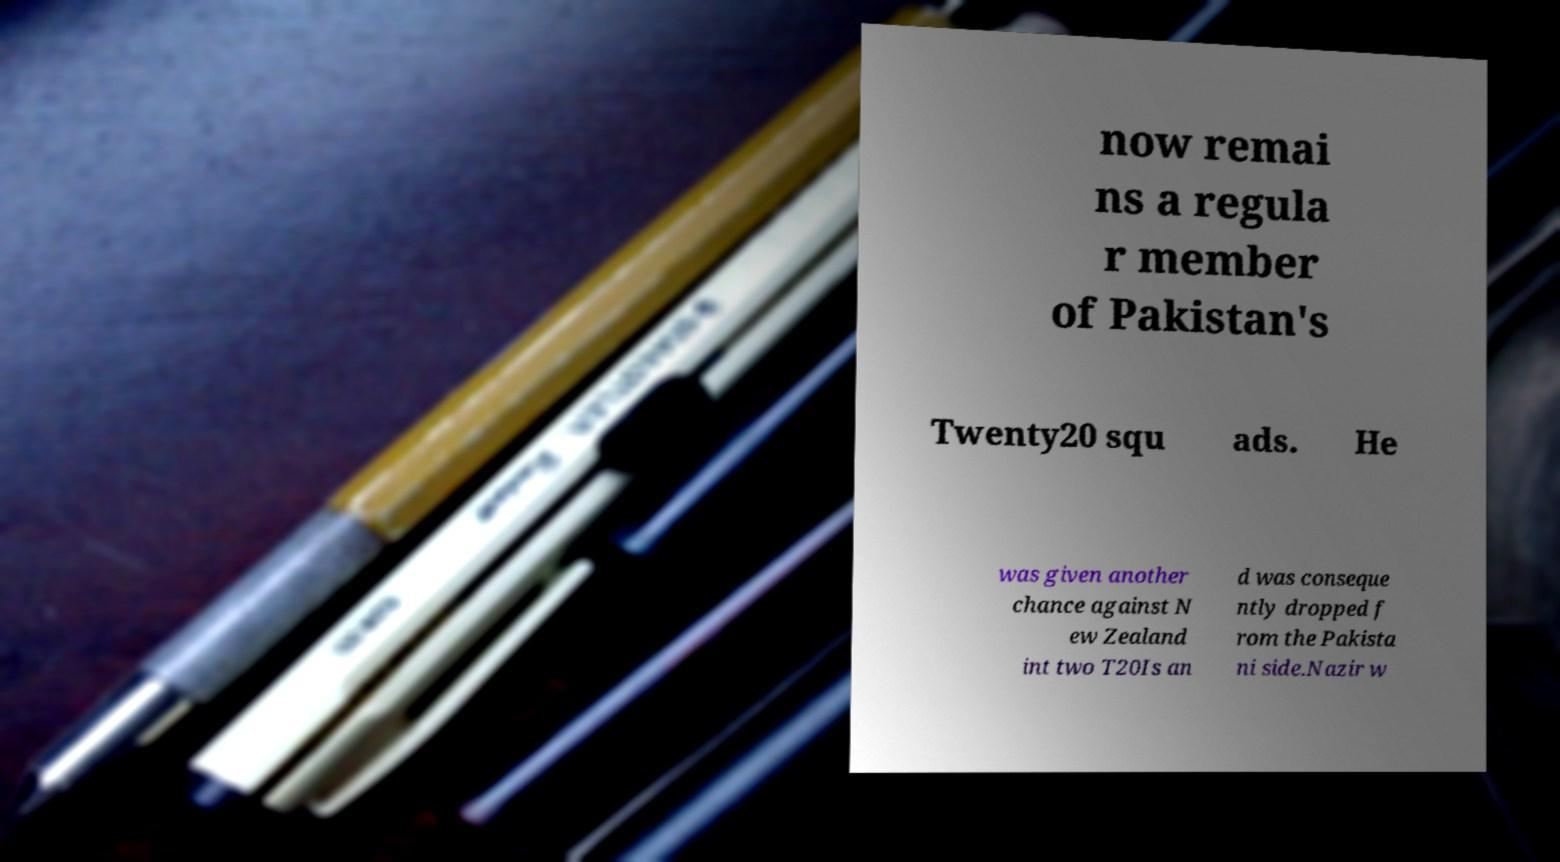For documentation purposes, I need the text within this image transcribed. Could you provide that? now remai ns a regula r member of Pakistan's Twenty20 squ ads. He was given another chance against N ew Zealand int two T20Is an d was conseque ntly dropped f rom the Pakista ni side.Nazir w 